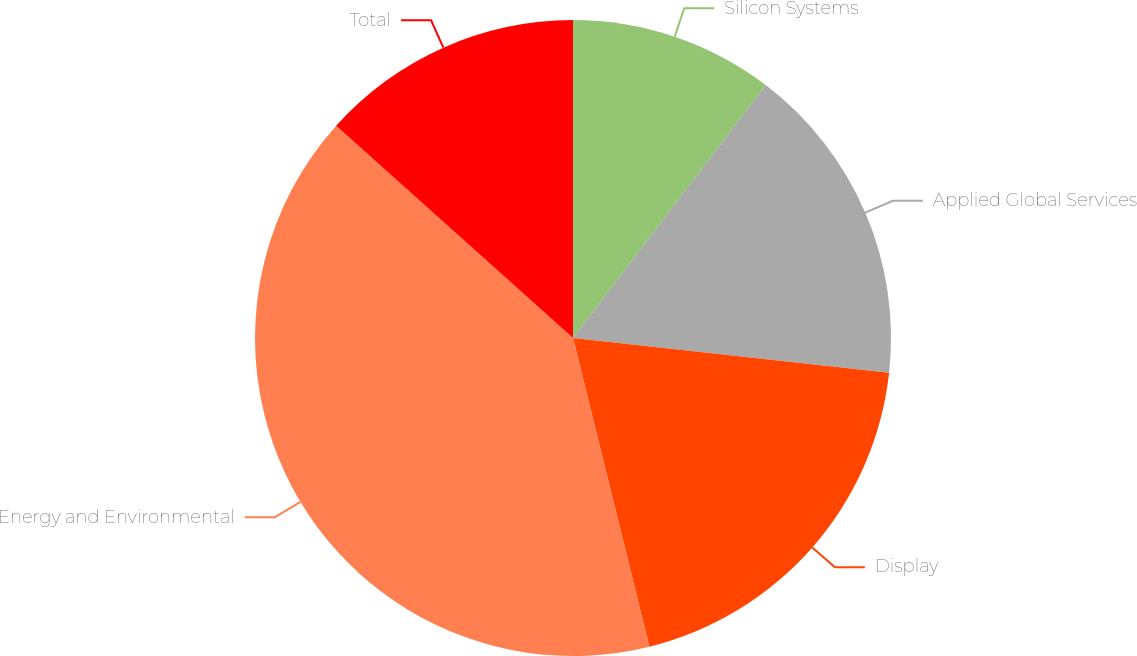Convert chart to OTSL. <chart><loc_0><loc_0><loc_500><loc_500><pie_chart><fcel>Silicon Systems<fcel>Applied Global Services<fcel>Display<fcel>Energy and Environmental<fcel>Total<nl><fcel>10.36%<fcel>16.38%<fcel>19.4%<fcel>40.49%<fcel>13.37%<nl></chart> 